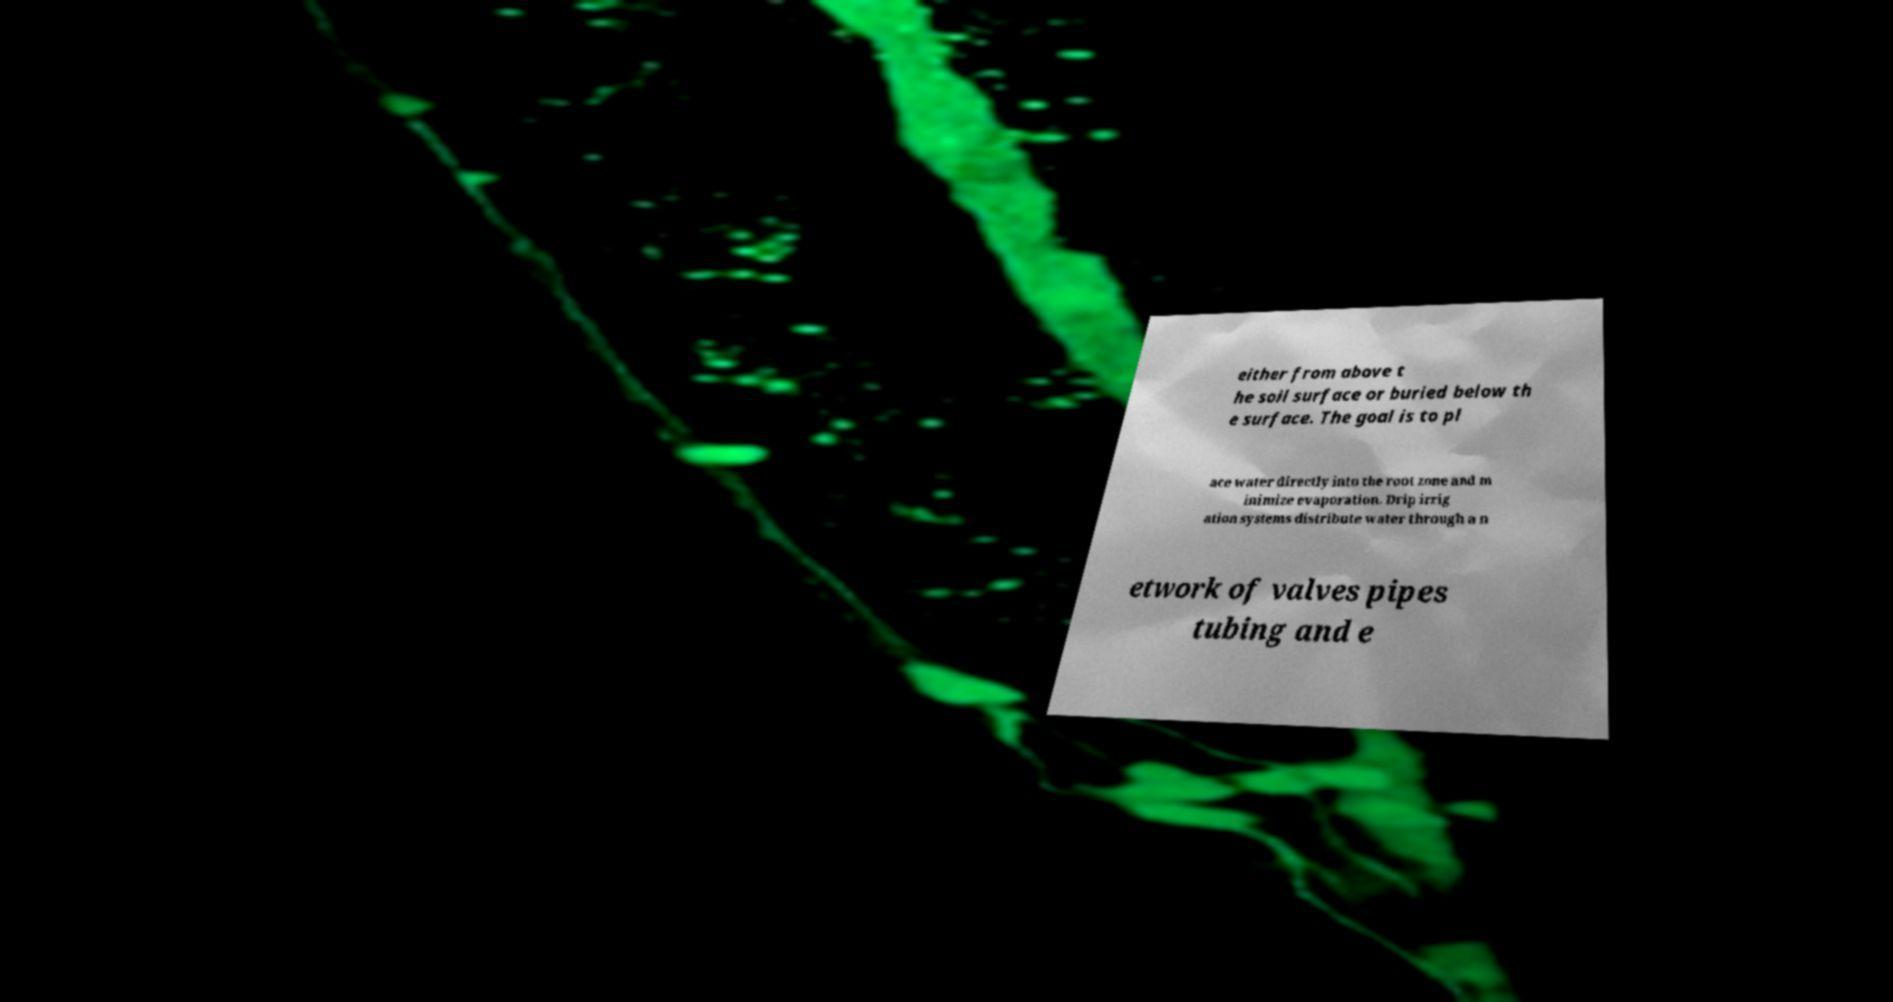Please identify and transcribe the text found in this image. either from above t he soil surface or buried below th e surface. The goal is to pl ace water directly into the root zone and m inimize evaporation. Drip irrig ation systems distribute water through a n etwork of valves pipes tubing and e 